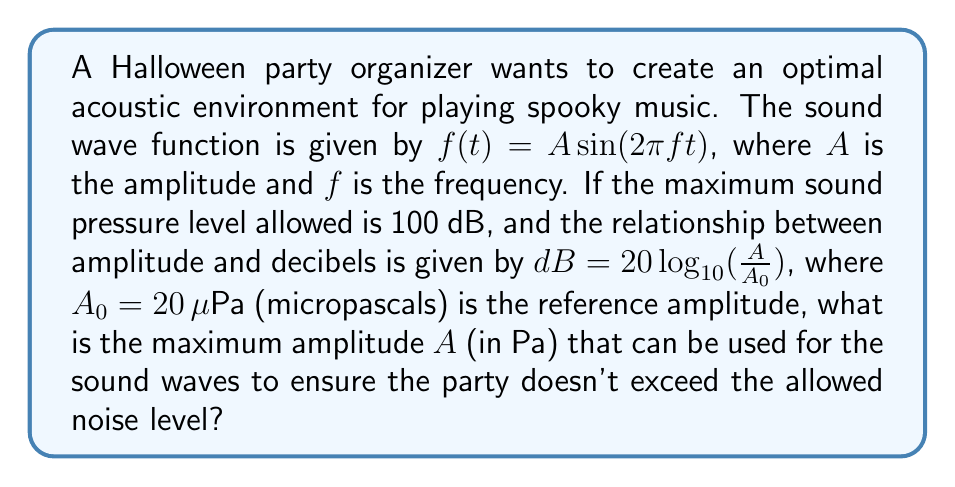Help me with this question. To solve this problem, we'll follow these steps:

1) We're given the equation relating decibels to amplitude:
   $dB = 20 \log_{10}(\frac{A}{A_0})$

2) We know the maximum allowed sound pressure level is 100 dB, so we can substitute this:
   $100 = 20 \log_{10}(\frac{A}{A_0})$

3) We're also given that $A_0 = 20 \mu Pa = 2 \times 10^{-5} Pa$

4) Now, let's solve the equation for $A$:
   $\frac{100}{20} = \log_{10}(\frac{A}{2 \times 10^{-5}})$
   
   $5 = \log_{10}(\frac{A}{2 \times 10^{-5}})$

5) To remove the logarithm, we can use the fact that if $\log_{10}(x) = y$, then $10^y = x$:
   $10^5 = \frac{A}{2 \times 10^{-5}}$

6) Now we can solve for $A$:
   $A = 2 \times 10^{-5} \times 10^5 = 2 Pa$

Therefore, the maximum amplitude that can be used is 2 Pa.
Answer: 2 Pa 